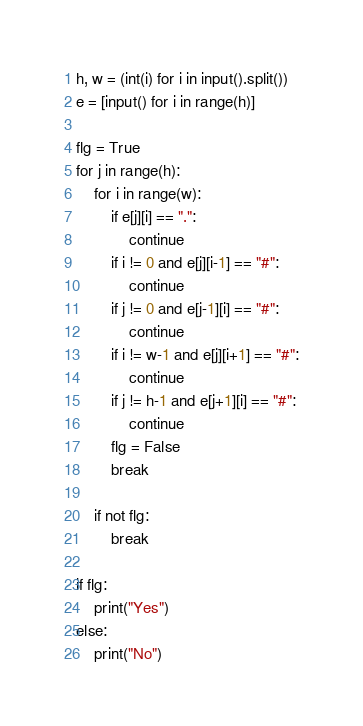Convert code to text. <code><loc_0><loc_0><loc_500><loc_500><_Python_>h, w = (int(i) for i in input().split())
e = [input() for i in range(h)]

flg = True
for j in range(h):
    for i in range(w):
        if e[j][i] == ".":
            continue
        if i != 0 and e[j][i-1] == "#":
            continue
        if j != 0 and e[j-1][i] == "#":
            continue
        if i != w-1 and e[j][i+1] == "#":
            continue
        if j != h-1 and e[j+1][i] == "#":
            continue
        flg = False
        break

    if not flg:
        break

if flg:
    print("Yes")
else:
    print("No")</code> 